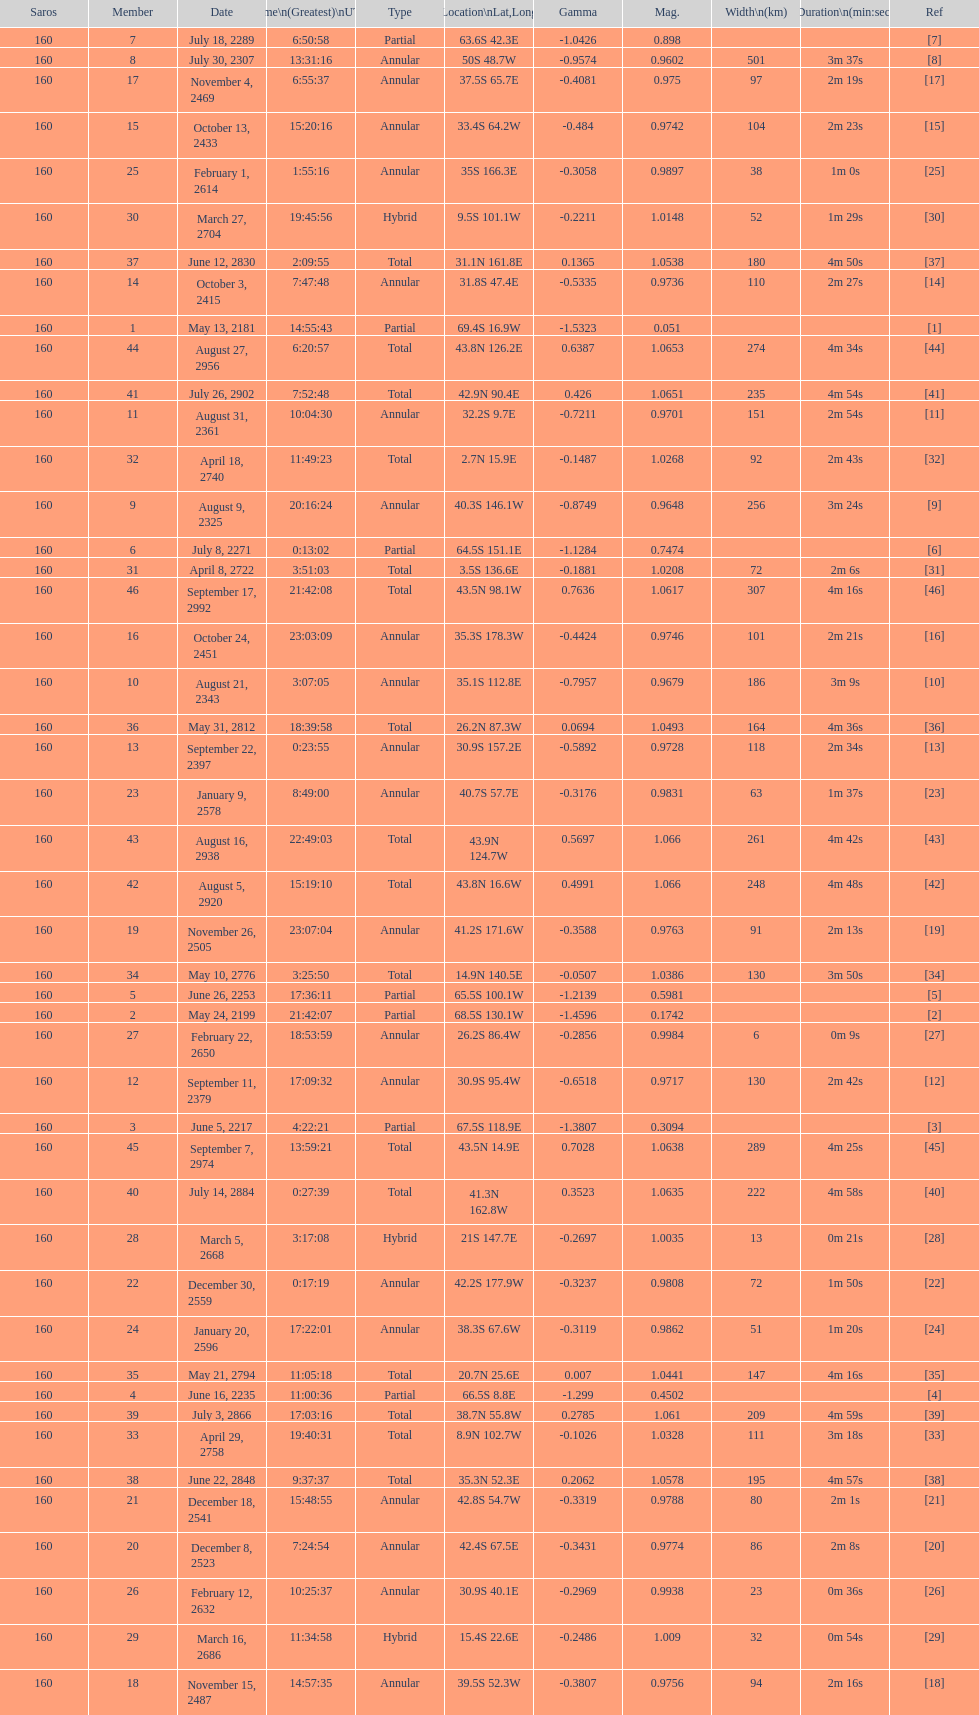Name a member number with a latitude above 60 s. 1. 